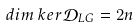Convert formula to latex. <formula><loc_0><loc_0><loc_500><loc_500>d i m { \, } k e r \mathcal { D } _ { L G } = 2 n</formula> 